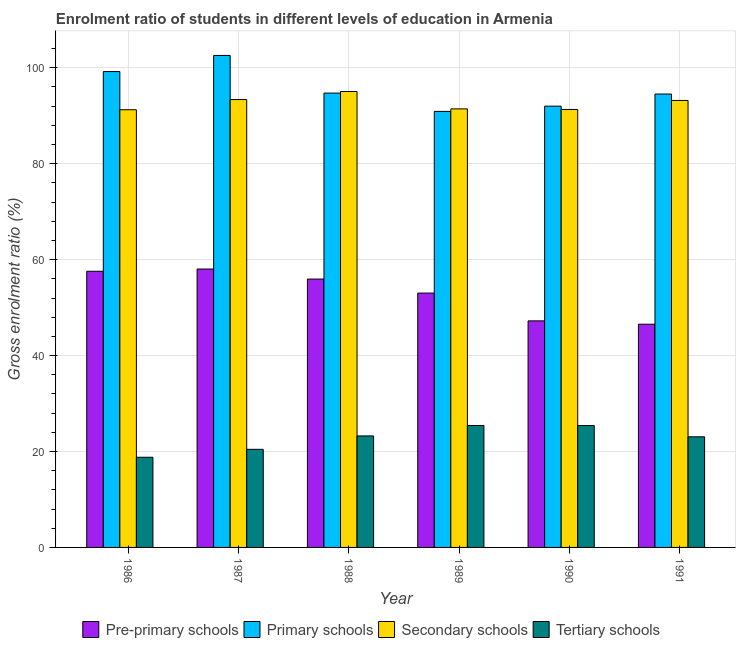How many groups of bars are there?
Keep it short and to the point. 6. Are the number of bars on each tick of the X-axis equal?
Offer a terse response. Yes. How many bars are there on the 3rd tick from the right?
Offer a terse response. 4. What is the label of the 3rd group of bars from the left?
Provide a succinct answer. 1988. In how many cases, is the number of bars for a given year not equal to the number of legend labels?
Your answer should be very brief. 0. What is the gross enrolment ratio in tertiary schools in 1988?
Give a very brief answer. 23.25. Across all years, what is the maximum gross enrolment ratio in secondary schools?
Your answer should be compact. 95.06. Across all years, what is the minimum gross enrolment ratio in pre-primary schools?
Offer a very short reply. 46.54. In which year was the gross enrolment ratio in primary schools maximum?
Offer a very short reply. 1987. In which year was the gross enrolment ratio in primary schools minimum?
Your answer should be very brief. 1989. What is the total gross enrolment ratio in secondary schools in the graph?
Offer a terse response. 555.62. What is the difference between the gross enrolment ratio in pre-primary schools in 1988 and that in 1991?
Your answer should be compact. 9.41. What is the difference between the gross enrolment ratio in primary schools in 1990 and the gross enrolment ratio in tertiary schools in 1987?
Ensure brevity in your answer.  -10.58. What is the average gross enrolment ratio in primary schools per year?
Give a very brief answer. 95.66. In the year 1987, what is the difference between the gross enrolment ratio in pre-primary schools and gross enrolment ratio in primary schools?
Make the answer very short. 0. In how many years, is the gross enrolment ratio in primary schools greater than 4 %?
Provide a short and direct response. 6. What is the ratio of the gross enrolment ratio in primary schools in 1988 to that in 1990?
Ensure brevity in your answer.  1.03. Is the gross enrolment ratio in primary schools in 1989 less than that in 1990?
Ensure brevity in your answer.  Yes. Is the difference between the gross enrolment ratio in secondary schools in 1988 and 1991 greater than the difference between the gross enrolment ratio in primary schools in 1988 and 1991?
Give a very brief answer. No. What is the difference between the highest and the second highest gross enrolment ratio in primary schools?
Make the answer very short. 3.36. What is the difference between the highest and the lowest gross enrolment ratio in primary schools?
Ensure brevity in your answer.  11.67. In how many years, is the gross enrolment ratio in tertiary schools greater than the average gross enrolment ratio in tertiary schools taken over all years?
Your answer should be very brief. 4. Is the sum of the gross enrolment ratio in pre-primary schools in 1989 and 1991 greater than the maximum gross enrolment ratio in tertiary schools across all years?
Provide a short and direct response. Yes. What does the 4th bar from the left in 1990 represents?
Offer a terse response. Tertiary schools. What does the 2nd bar from the right in 1986 represents?
Make the answer very short. Secondary schools. Is it the case that in every year, the sum of the gross enrolment ratio in pre-primary schools and gross enrolment ratio in primary schools is greater than the gross enrolment ratio in secondary schools?
Offer a terse response. Yes. How many bars are there?
Give a very brief answer. 24. How many years are there in the graph?
Your response must be concise. 6. Are the values on the major ticks of Y-axis written in scientific E-notation?
Provide a succinct answer. No. Does the graph contain any zero values?
Give a very brief answer. No. Where does the legend appear in the graph?
Make the answer very short. Bottom center. How many legend labels are there?
Your answer should be compact. 4. What is the title of the graph?
Ensure brevity in your answer.  Enrolment ratio of students in different levels of education in Armenia. What is the label or title of the X-axis?
Offer a very short reply. Year. What is the label or title of the Y-axis?
Your answer should be compact. Gross enrolment ratio (%). What is the Gross enrolment ratio (%) of Pre-primary schools in 1986?
Offer a very short reply. 57.58. What is the Gross enrolment ratio (%) of Primary schools in 1986?
Give a very brief answer. 99.21. What is the Gross enrolment ratio (%) in Secondary schools in 1986?
Provide a short and direct response. 91.25. What is the Gross enrolment ratio (%) in Tertiary schools in 1986?
Your answer should be very brief. 18.8. What is the Gross enrolment ratio (%) of Pre-primary schools in 1987?
Make the answer very short. 58.04. What is the Gross enrolment ratio (%) in Primary schools in 1987?
Make the answer very short. 102.58. What is the Gross enrolment ratio (%) of Secondary schools in 1987?
Your answer should be compact. 93.37. What is the Gross enrolment ratio (%) of Tertiary schools in 1987?
Your answer should be compact. 20.45. What is the Gross enrolment ratio (%) of Pre-primary schools in 1988?
Offer a terse response. 55.95. What is the Gross enrolment ratio (%) of Primary schools in 1988?
Ensure brevity in your answer.  94.73. What is the Gross enrolment ratio (%) in Secondary schools in 1988?
Provide a succinct answer. 95.06. What is the Gross enrolment ratio (%) of Tertiary schools in 1988?
Provide a short and direct response. 23.25. What is the Gross enrolment ratio (%) of Pre-primary schools in 1989?
Offer a terse response. 53.03. What is the Gross enrolment ratio (%) in Primary schools in 1989?
Keep it short and to the point. 90.91. What is the Gross enrolment ratio (%) in Secondary schools in 1989?
Your answer should be compact. 91.43. What is the Gross enrolment ratio (%) of Tertiary schools in 1989?
Your answer should be very brief. 25.42. What is the Gross enrolment ratio (%) in Pre-primary schools in 1990?
Offer a very short reply. 47.23. What is the Gross enrolment ratio (%) in Primary schools in 1990?
Ensure brevity in your answer.  92. What is the Gross enrolment ratio (%) in Secondary schools in 1990?
Give a very brief answer. 91.31. What is the Gross enrolment ratio (%) in Tertiary schools in 1990?
Keep it short and to the point. 25.41. What is the Gross enrolment ratio (%) of Pre-primary schools in 1991?
Give a very brief answer. 46.54. What is the Gross enrolment ratio (%) in Primary schools in 1991?
Provide a succinct answer. 94.53. What is the Gross enrolment ratio (%) of Secondary schools in 1991?
Offer a terse response. 93.19. What is the Gross enrolment ratio (%) of Tertiary schools in 1991?
Your answer should be very brief. 23.06. Across all years, what is the maximum Gross enrolment ratio (%) of Pre-primary schools?
Offer a very short reply. 58.04. Across all years, what is the maximum Gross enrolment ratio (%) in Primary schools?
Keep it short and to the point. 102.58. Across all years, what is the maximum Gross enrolment ratio (%) of Secondary schools?
Provide a succinct answer. 95.06. Across all years, what is the maximum Gross enrolment ratio (%) of Tertiary schools?
Your answer should be very brief. 25.42. Across all years, what is the minimum Gross enrolment ratio (%) of Pre-primary schools?
Your answer should be compact. 46.54. Across all years, what is the minimum Gross enrolment ratio (%) of Primary schools?
Give a very brief answer. 90.91. Across all years, what is the minimum Gross enrolment ratio (%) of Secondary schools?
Provide a succinct answer. 91.25. Across all years, what is the minimum Gross enrolment ratio (%) in Tertiary schools?
Give a very brief answer. 18.8. What is the total Gross enrolment ratio (%) in Pre-primary schools in the graph?
Your answer should be very brief. 318.37. What is the total Gross enrolment ratio (%) in Primary schools in the graph?
Offer a very short reply. 573.95. What is the total Gross enrolment ratio (%) of Secondary schools in the graph?
Ensure brevity in your answer.  555.62. What is the total Gross enrolment ratio (%) of Tertiary schools in the graph?
Your answer should be compact. 136.39. What is the difference between the Gross enrolment ratio (%) of Pre-primary schools in 1986 and that in 1987?
Ensure brevity in your answer.  -0.46. What is the difference between the Gross enrolment ratio (%) of Primary schools in 1986 and that in 1987?
Make the answer very short. -3.36. What is the difference between the Gross enrolment ratio (%) in Secondary schools in 1986 and that in 1987?
Provide a short and direct response. -2.12. What is the difference between the Gross enrolment ratio (%) in Tertiary schools in 1986 and that in 1987?
Offer a terse response. -1.65. What is the difference between the Gross enrolment ratio (%) in Pre-primary schools in 1986 and that in 1988?
Give a very brief answer. 1.63. What is the difference between the Gross enrolment ratio (%) in Primary schools in 1986 and that in 1988?
Offer a very short reply. 4.49. What is the difference between the Gross enrolment ratio (%) in Secondary schools in 1986 and that in 1988?
Provide a short and direct response. -3.81. What is the difference between the Gross enrolment ratio (%) of Tertiary schools in 1986 and that in 1988?
Keep it short and to the point. -4.45. What is the difference between the Gross enrolment ratio (%) of Pre-primary schools in 1986 and that in 1989?
Your answer should be very brief. 4.55. What is the difference between the Gross enrolment ratio (%) of Primary schools in 1986 and that in 1989?
Your answer should be very brief. 8.31. What is the difference between the Gross enrolment ratio (%) in Secondary schools in 1986 and that in 1989?
Give a very brief answer. -0.18. What is the difference between the Gross enrolment ratio (%) of Tertiary schools in 1986 and that in 1989?
Give a very brief answer. -6.62. What is the difference between the Gross enrolment ratio (%) of Pre-primary schools in 1986 and that in 1990?
Make the answer very short. 10.34. What is the difference between the Gross enrolment ratio (%) in Primary schools in 1986 and that in 1990?
Offer a very short reply. 7.21. What is the difference between the Gross enrolment ratio (%) in Secondary schools in 1986 and that in 1990?
Offer a terse response. -0.06. What is the difference between the Gross enrolment ratio (%) of Tertiary schools in 1986 and that in 1990?
Offer a terse response. -6.61. What is the difference between the Gross enrolment ratio (%) of Pre-primary schools in 1986 and that in 1991?
Give a very brief answer. 11.04. What is the difference between the Gross enrolment ratio (%) in Primary schools in 1986 and that in 1991?
Keep it short and to the point. 4.69. What is the difference between the Gross enrolment ratio (%) in Secondary schools in 1986 and that in 1991?
Give a very brief answer. -1.94. What is the difference between the Gross enrolment ratio (%) in Tertiary schools in 1986 and that in 1991?
Provide a short and direct response. -4.27. What is the difference between the Gross enrolment ratio (%) of Pre-primary schools in 1987 and that in 1988?
Offer a terse response. 2.1. What is the difference between the Gross enrolment ratio (%) in Primary schools in 1987 and that in 1988?
Offer a very short reply. 7.85. What is the difference between the Gross enrolment ratio (%) of Secondary schools in 1987 and that in 1988?
Keep it short and to the point. -1.69. What is the difference between the Gross enrolment ratio (%) in Tertiary schools in 1987 and that in 1988?
Ensure brevity in your answer.  -2.79. What is the difference between the Gross enrolment ratio (%) in Pre-primary schools in 1987 and that in 1989?
Provide a short and direct response. 5.01. What is the difference between the Gross enrolment ratio (%) in Primary schools in 1987 and that in 1989?
Offer a very short reply. 11.67. What is the difference between the Gross enrolment ratio (%) of Secondary schools in 1987 and that in 1989?
Offer a terse response. 1.94. What is the difference between the Gross enrolment ratio (%) of Tertiary schools in 1987 and that in 1989?
Provide a succinct answer. -4.97. What is the difference between the Gross enrolment ratio (%) in Pre-primary schools in 1987 and that in 1990?
Ensure brevity in your answer.  10.81. What is the difference between the Gross enrolment ratio (%) of Primary schools in 1987 and that in 1990?
Offer a terse response. 10.58. What is the difference between the Gross enrolment ratio (%) of Secondary schools in 1987 and that in 1990?
Your answer should be compact. 2.06. What is the difference between the Gross enrolment ratio (%) in Tertiary schools in 1987 and that in 1990?
Offer a terse response. -4.95. What is the difference between the Gross enrolment ratio (%) of Pre-primary schools in 1987 and that in 1991?
Provide a succinct answer. 11.5. What is the difference between the Gross enrolment ratio (%) of Primary schools in 1987 and that in 1991?
Provide a short and direct response. 8.05. What is the difference between the Gross enrolment ratio (%) of Secondary schools in 1987 and that in 1991?
Give a very brief answer. 0.18. What is the difference between the Gross enrolment ratio (%) in Tertiary schools in 1987 and that in 1991?
Offer a terse response. -2.61. What is the difference between the Gross enrolment ratio (%) of Pre-primary schools in 1988 and that in 1989?
Make the answer very short. 2.92. What is the difference between the Gross enrolment ratio (%) of Primary schools in 1988 and that in 1989?
Keep it short and to the point. 3.82. What is the difference between the Gross enrolment ratio (%) of Secondary schools in 1988 and that in 1989?
Your answer should be compact. 3.63. What is the difference between the Gross enrolment ratio (%) in Tertiary schools in 1988 and that in 1989?
Provide a succinct answer. -2.17. What is the difference between the Gross enrolment ratio (%) of Pre-primary schools in 1988 and that in 1990?
Keep it short and to the point. 8.71. What is the difference between the Gross enrolment ratio (%) in Primary schools in 1988 and that in 1990?
Offer a very short reply. 2.72. What is the difference between the Gross enrolment ratio (%) in Secondary schools in 1988 and that in 1990?
Your response must be concise. 3.75. What is the difference between the Gross enrolment ratio (%) of Tertiary schools in 1988 and that in 1990?
Offer a terse response. -2.16. What is the difference between the Gross enrolment ratio (%) of Pre-primary schools in 1988 and that in 1991?
Keep it short and to the point. 9.41. What is the difference between the Gross enrolment ratio (%) of Primary schools in 1988 and that in 1991?
Provide a short and direct response. 0.2. What is the difference between the Gross enrolment ratio (%) of Secondary schools in 1988 and that in 1991?
Your response must be concise. 1.87. What is the difference between the Gross enrolment ratio (%) of Tertiary schools in 1988 and that in 1991?
Provide a succinct answer. 0.18. What is the difference between the Gross enrolment ratio (%) of Pre-primary schools in 1989 and that in 1990?
Ensure brevity in your answer.  5.79. What is the difference between the Gross enrolment ratio (%) of Primary schools in 1989 and that in 1990?
Provide a succinct answer. -1.1. What is the difference between the Gross enrolment ratio (%) of Secondary schools in 1989 and that in 1990?
Keep it short and to the point. 0.12. What is the difference between the Gross enrolment ratio (%) of Tertiary schools in 1989 and that in 1990?
Your answer should be very brief. 0.01. What is the difference between the Gross enrolment ratio (%) in Pre-primary schools in 1989 and that in 1991?
Provide a short and direct response. 6.49. What is the difference between the Gross enrolment ratio (%) in Primary schools in 1989 and that in 1991?
Your answer should be very brief. -3.62. What is the difference between the Gross enrolment ratio (%) in Secondary schools in 1989 and that in 1991?
Your response must be concise. -1.76. What is the difference between the Gross enrolment ratio (%) of Tertiary schools in 1989 and that in 1991?
Ensure brevity in your answer.  2.36. What is the difference between the Gross enrolment ratio (%) of Pre-primary schools in 1990 and that in 1991?
Make the answer very short. 0.7. What is the difference between the Gross enrolment ratio (%) of Primary schools in 1990 and that in 1991?
Offer a very short reply. -2.52. What is the difference between the Gross enrolment ratio (%) of Secondary schools in 1990 and that in 1991?
Your response must be concise. -1.88. What is the difference between the Gross enrolment ratio (%) in Tertiary schools in 1990 and that in 1991?
Your response must be concise. 2.34. What is the difference between the Gross enrolment ratio (%) of Pre-primary schools in 1986 and the Gross enrolment ratio (%) of Primary schools in 1987?
Ensure brevity in your answer.  -45. What is the difference between the Gross enrolment ratio (%) of Pre-primary schools in 1986 and the Gross enrolment ratio (%) of Secondary schools in 1987?
Provide a short and direct response. -35.79. What is the difference between the Gross enrolment ratio (%) of Pre-primary schools in 1986 and the Gross enrolment ratio (%) of Tertiary schools in 1987?
Your answer should be very brief. 37.13. What is the difference between the Gross enrolment ratio (%) of Primary schools in 1986 and the Gross enrolment ratio (%) of Secondary schools in 1987?
Provide a short and direct response. 5.84. What is the difference between the Gross enrolment ratio (%) of Primary schools in 1986 and the Gross enrolment ratio (%) of Tertiary schools in 1987?
Your response must be concise. 78.76. What is the difference between the Gross enrolment ratio (%) of Secondary schools in 1986 and the Gross enrolment ratio (%) of Tertiary schools in 1987?
Your answer should be compact. 70.8. What is the difference between the Gross enrolment ratio (%) in Pre-primary schools in 1986 and the Gross enrolment ratio (%) in Primary schools in 1988?
Your response must be concise. -37.15. What is the difference between the Gross enrolment ratio (%) in Pre-primary schools in 1986 and the Gross enrolment ratio (%) in Secondary schools in 1988?
Keep it short and to the point. -37.48. What is the difference between the Gross enrolment ratio (%) in Pre-primary schools in 1986 and the Gross enrolment ratio (%) in Tertiary schools in 1988?
Give a very brief answer. 34.33. What is the difference between the Gross enrolment ratio (%) of Primary schools in 1986 and the Gross enrolment ratio (%) of Secondary schools in 1988?
Ensure brevity in your answer.  4.15. What is the difference between the Gross enrolment ratio (%) in Primary schools in 1986 and the Gross enrolment ratio (%) in Tertiary schools in 1988?
Provide a short and direct response. 75.97. What is the difference between the Gross enrolment ratio (%) of Secondary schools in 1986 and the Gross enrolment ratio (%) of Tertiary schools in 1988?
Your answer should be very brief. 68.01. What is the difference between the Gross enrolment ratio (%) in Pre-primary schools in 1986 and the Gross enrolment ratio (%) in Primary schools in 1989?
Give a very brief answer. -33.33. What is the difference between the Gross enrolment ratio (%) in Pre-primary schools in 1986 and the Gross enrolment ratio (%) in Secondary schools in 1989?
Your answer should be very brief. -33.85. What is the difference between the Gross enrolment ratio (%) in Pre-primary schools in 1986 and the Gross enrolment ratio (%) in Tertiary schools in 1989?
Offer a very short reply. 32.16. What is the difference between the Gross enrolment ratio (%) of Primary schools in 1986 and the Gross enrolment ratio (%) of Secondary schools in 1989?
Offer a very short reply. 7.78. What is the difference between the Gross enrolment ratio (%) of Primary schools in 1986 and the Gross enrolment ratio (%) of Tertiary schools in 1989?
Make the answer very short. 73.79. What is the difference between the Gross enrolment ratio (%) of Secondary schools in 1986 and the Gross enrolment ratio (%) of Tertiary schools in 1989?
Ensure brevity in your answer.  65.83. What is the difference between the Gross enrolment ratio (%) of Pre-primary schools in 1986 and the Gross enrolment ratio (%) of Primary schools in 1990?
Make the answer very short. -34.42. What is the difference between the Gross enrolment ratio (%) in Pre-primary schools in 1986 and the Gross enrolment ratio (%) in Secondary schools in 1990?
Offer a terse response. -33.73. What is the difference between the Gross enrolment ratio (%) of Pre-primary schools in 1986 and the Gross enrolment ratio (%) of Tertiary schools in 1990?
Make the answer very short. 32.17. What is the difference between the Gross enrolment ratio (%) of Primary schools in 1986 and the Gross enrolment ratio (%) of Secondary schools in 1990?
Your answer should be very brief. 7.9. What is the difference between the Gross enrolment ratio (%) in Primary schools in 1986 and the Gross enrolment ratio (%) in Tertiary schools in 1990?
Your answer should be compact. 73.81. What is the difference between the Gross enrolment ratio (%) in Secondary schools in 1986 and the Gross enrolment ratio (%) in Tertiary schools in 1990?
Offer a very short reply. 65.84. What is the difference between the Gross enrolment ratio (%) of Pre-primary schools in 1986 and the Gross enrolment ratio (%) of Primary schools in 1991?
Your response must be concise. -36.95. What is the difference between the Gross enrolment ratio (%) of Pre-primary schools in 1986 and the Gross enrolment ratio (%) of Secondary schools in 1991?
Offer a very short reply. -35.61. What is the difference between the Gross enrolment ratio (%) in Pre-primary schools in 1986 and the Gross enrolment ratio (%) in Tertiary schools in 1991?
Your answer should be compact. 34.51. What is the difference between the Gross enrolment ratio (%) in Primary schools in 1986 and the Gross enrolment ratio (%) in Secondary schools in 1991?
Ensure brevity in your answer.  6.02. What is the difference between the Gross enrolment ratio (%) of Primary schools in 1986 and the Gross enrolment ratio (%) of Tertiary schools in 1991?
Your answer should be compact. 76.15. What is the difference between the Gross enrolment ratio (%) in Secondary schools in 1986 and the Gross enrolment ratio (%) in Tertiary schools in 1991?
Give a very brief answer. 68.19. What is the difference between the Gross enrolment ratio (%) of Pre-primary schools in 1987 and the Gross enrolment ratio (%) of Primary schools in 1988?
Ensure brevity in your answer.  -36.68. What is the difference between the Gross enrolment ratio (%) in Pre-primary schools in 1987 and the Gross enrolment ratio (%) in Secondary schools in 1988?
Make the answer very short. -37.02. What is the difference between the Gross enrolment ratio (%) of Pre-primary schools in 1987 and the Gross enrolment ratio (%) of Tertiary schools in 1988?
Offer a terse response. 34.8. What is the difference between the Gross enrolment ratio (%) in Primary schools in 1987 and the Gross enrolment ratio (%) in Secondary schools in 1988?
Give a very brief answer. 7.52. What is the difference between the Gross enrolment ratio (%) of Primary schools in 1987 and the Gross enrolment ratio (%) of Tertiary schools in 1988?
Your response must be concise. 79.33. What is the difference between the Gross enrolment ratio (%) of Secondary schools in 1987 and the Gross enrolment ratio (%) of Tertiary schools in 1988?
Ensure brevity in your answer.  70.13. What is the difference between the Gross enrolment ratio (%) of Pre-primary schools in 1987 and the Gross enrolment ratio (%) of Primary schools in 1989?
Make the answer very short. -32.86. What is the difference between the Gross enrolment ratio (%) in Pre-primary schools in 1987 and the Gross enrolment ratio (%) in Secondary schools in 1989?
Offer a very short reply. -33.39. What is the difference between the Gross enrolment ratio (%) of Pre-primary schools in 1987 and the Gross enrolment ratio (%) of Tertiary schools in 1989?
Provide a succinct answer. 32.62. What is the difference between the Gross enrolment ratio (%) in Primary schools in 1987 and the Gross enrolment ratio (%) in Secondary schools in 1989?
Provide a short and direct response. 11.15. What is the difference between the Gross enrolment ratio (%) in Primary schools in 1987 and the Gross enrolment ratio (%) in Tertiary schools in 1989?
Make the answer very short. 77.16. What is the difference between the Gross enrolment ratio (%) of Secondary schools in 1987 and the Gross enrolment ratio (%) of Tertiary schools in 1989?
Keep it short and to the point. 67.95. What is the difference between the Gross enrolment ratio (%) of Pre-primary schools in 1987 and the Gross enrolment ratio (%) of Primary schools in 1990?
Provide a succinct answer. -33.96. What is the difference between the Gross enrolment ratio (%) of Pre-primary schools in 1987 and the Gross enrolment ratio (%) of Secondary schools in 1990?
Provide a short and direct response. -33.27. What is the difference between the Gross enrolment ratio (%) in Pre-primary schools in 1987 and the Gross enrolment ratio (%) in Tertiary schools in 1990?
Keep it short and to the point. 32.64. What is the difference between the Gross enrolment ratio (%) of Primary schools in 1987 and the Gross enrolment ratio (%) of Secondary schools in 1990?
Make the answer very short. 11.27. What is the difference between the Gross enrolment ratio (%) of Primary schools in 1987 and the Gross enrolment ratio (%) of Tertiary schools in 1990?
Ensure brevity in your answer.  77.17. What is the difference between the Gross enrolment ratio (%) of Secondary schools in 1987 and the Gross enrolment ratio (%) of Tertiary schools in 1990?
Your answer should be compact. 67.97. What is the difference between the Gross enrolment ratio (%) in Pre-primary schools in 1987 and the Gross enrolment ratio (%) in Primary schools in 1991?
Your answer should be very brief. -36.48. What is the difference between the Gross enrolment ratio (%) in Pre-primary schools in 1987 and the Gross enrolment ratio (%) in Secondary schools in 1991?
Provide a succinct answer. -35.15. What is the difference between the Gross enrolment ratio (%) in Pre-primary schools in 1987 and the Gross enrolment ratio (%) in Tertiary schools in 1991?
Your answer should be compact. 34.98. What is the difference between the Gross enrolment ratio (%) in Primary schools in 1987 and the Gross enrolment ratio (%) in Secondary schools in 1991?
Your answer should be very brief. 9.38. What is the difference between the Gross enrolment ratio (%) of Primary schools in 1987 and the Gross enrolment ratio (%) of Tertiary schools in 1991?
Your response must be concise. 79.51. What is the difference between the Gross enrolment ratio (%) in Secondary schools in 1987 and the Gross enrolment ratio (%) in Tertiary schools in 1991?
Keep it short and to the point. 70.31. What is the difference between the Gross enrolment ratio (%) in Pre-primary schools in 1988 and the Gross enrolment ratio (%) in Primary schools in 1989?
Provide a short and direct response. -34.96. What is the difference between the Gross enrolment ratio (%) of Pre-primary schools in 1988 and the Gross enrolment ratio (%) of Secondary schools in 1989?
Ensure brevity in your answer.  -35.48. What is the difference between the Gross enrolment ratio (%) in Pre-primary schools in 1988 and the Gross enrolment ratio (%) in Tertiary schools in 1989?
Make the answer very short. 30.53. What is the difference between the Gross enrolment ratio (%) of Primary schools in 1988 and the Gross enrolment ratio (%) of Secondary schools in 1989?
Your answer should be compact. 3.29. What is the difference between the Gross enrolment ratio (%) of Primary schools in 1988 and the Gross enrolment ratio (%) of Tertiary schools in 1989?
Keep it short and to the point. 69.3. What is the difference between the Gross enrolment ratio (%) of Secondary schools in 1988 and the Gross enrolment ratio (%) of Tertiary schools in 1989?
Offer a terse response. 69.64. What is the difference between the Gross enrolment ratio (%) in Pre-primary schools in 1988 and the Gross enrolment ratio (%) in Primary schools in 1990?
Your answer should be very brief. -36.05. What is the difference between the Gross enrolment ratio (%) in Pre-primary schools in 1988 and the Gross enrolment ratio (%) in Secondary schools in 1990?
Provide a succinct answer. -35.36. What is the difference between the Gross enrolment ratio (%) in Pre-primary schools in 1988 and the Gross enrolment ratio (%) in Tertiary schools in 1990?
Keep it short and to the point. 30.54. What is the difference between the Gross enrolment ratio (%) of Primary schools in 1988 and the Gross enrolment ratio (%) of Secondary schools in 1990?
Give a very brief answer. 3.42. What is the difference between the Gross enrolment ratio (%) of Primary schools in 1988 and the Gross enrolment ratio (%) of Tertiary schools in 1990?
Your response must be concise. 69.32. What is the difference between the Gross enrolment ratio (%) in Secondary schools in 1988 and the Gross enrolment ratio (%) in Tertiary schools in 1990?
Keep it short and to the point. 69.65. What is the difference between the Gross enrolment ratio (%) of Pre-primary schools in 1988 and the Gross enrolment ratio (%) of Primary schools in 1991?
Ensure brevity in your answer.  -38.58. What is the difference between the Gross enrolment ratio (%) in Pre-primary schools in 1988 and the Gross enrolment ratio (%) in Secondary schools in 1991?
Give a very brief answer. -37.25. What is the difference between the Gross enrolment ratio (%) in Pre-primary schools in 1988 and the Gross enrolment ratio (%) in Tertiary schools in 1991?
Provide a succinct answer. 32.88. What is the difference between the Gross enrolment ratio (%) of Primary schools in 1988 and the Gross enrolment ratio (%) of Secondary schools in 1991?
Your answer should be very brief. 1.53. What is the difference between the Gross enrolment ratio (%) of Primary schools in 1988 and the Gross enrolment ratio (%) of Tertiary schools in 1991?
Keep it short and to the point. 71.66. What is the difference between the Gross enrolment ratio (%) in Secondary schools in 1988 and the Gross enrolment ratio (%) in Tertiary schools in 1991?
Your response must be concise. 71.99. What is the difference between the Gross enrolment ratio (%) of Pre-primary schools in 1989 and the Gross enrolment ratio (%) of Primary schools in 1990?
Ensure brevity in your answer.  -38.97. What is the difference between the Gross enrolment ratio (%) in Pre-primary schools in 1989 and the Gross enrolment ratio (%) in Secondary schools in 1990?
Provide a succinct answer. -38.28. What is the difference between the Gross enrolment ratio (%) of Pre-primary schools in 1989 and the Gross enrolment ratio (%) of Tertiary schools in 1990?
Give a very brief answer. 27.62. What is the difference between the Gross enrolment ratio (%) of Primary schools in 1989 and the Gross enrolment ratio (%) of Secondary schools in 1990?
Your answer should be compact. -0.4. What is the difference between the Gross enrolment ratio (%) in Primary schools in 1989 and the Gross enrolment ratio (%) in Tertiary schools in 1990?
Provide a short and direct response. 65.5. What is the difference between the Gross enrolment ratio (%) of Secondary schools in 1989 and the Gross enrolment ratio (%) of Tertiary schools in 1990?
Make the answer very short. 66.02. What is the difference between the Gross enrolment ratio (%) in Pre-primary schools in 1989 and the Gross enrolment ratio (%) in Primary schools in 1991?
Keep it short and to the point. -41.5. What is the difference between the Gross enrolment ratio (%) of Pre-primary schools in 1989 and the Gross enrolment ratio (%) of Secondary schools in 1991?
Provide a succinct answer. -40.16. What is the difference between the Gross enrolment ratio (%) of Pre-primary schools in 1989 and the Gross enrolment ratio (%) of Tertiary schools in 1991?
Ensure brevity in your answer.  29.96. What is the difference between the Gross enrolment ratio (%) of Primary schools in 1989 and the Gross enrolment ratio (%) of Secondary schools in 1991?
Your answer should be compact. -2.29. What is the difference between the Gross enrolment ratio (%) of Primary schools in 1989 and the Gross enrolment ratio (%) of Tertiary schools in 1991?
Offer a terse response. 67.84. What is the difference between the Gross enrolment ratio (%) in Secondary schools in 1989 and the Gross enrolment ratio (%) in Tertiary schools in 1991?
Keep it short and to the point. 68.37. What is the difference between the Gross enrolment ratio (%) in Pre-primary schools in 1990 and the Gross enrolment ratio (%) in Primary schools in 1991?
Your answer should be compact. -47.29. What is the difference between the Gross enrolment ratio (%) of Pre-primary schools in 1990 and the Gross enrolment ratio (%) of Secondary schools in 1991?
Provide a succinct answer. -45.96. What is the difference between the Gross enrolment ratio (%) in Pre-primary schools in 1990 and the Gross enrolment ratio (%) in Tertiary schools in 1991?
Ensure brevity in your answer.  24.17. What is the difference between the Gross enrolment ratio (%) of Primary schools in 1990 and the Gross enrolment ratio (%) of Secondary schools in 1991?
Ensure brevity in your answer.  -1.19. What is the difference between the Gross enrolment ratio (%) of Primary schools in 1990 and the Gross enrolment ratio (%) of Tertiary schools in 1991?
Ensure brevity in your answer.  68.94. What is the difference between the Gross enrolment ratio (%) of Secondary schools in 1990 and the Gross enrolment ratio (%) of Tertiary schools in 1991?
Keep it short and to the point. 68.25. What is the average Gross enrolment ratio (%) in Pre-primary schools per year?
Your response must be concise. 53.06. What is the average Gross enrolment ratio (%) in Primary schools per year?
Make the answer very short. 95.66. What is the average Gross enrolment ratio (%) of Secondary schools per year?
Provide a succinct answer. 92.6. What is the average Gross enrolment ratio (%) of Tertiary schools per year?
Offer a very short reply. 22.73. In the year 1986, what is the difference between the Gross enrolment ratio (%) of Pre-primary schools and Gross enrolment ratio (%) of Primary schools?
Keep it short and to the point. -41.63. In the year 1986, what is the difference between the Gross enrolment ratio (%) of Pre-primary schools and Gross enrolment ratio (%) of Secondary schools?
Your answer should be very brief. -33.67. In the year 1986, what is the difference between the Gross enrolment ratio (%) of Pre-primary schools and Gross enrolment ratio (%) of Tertiary schools?
Make the answer very short. 38.78. In the year 1986, what is the difference between the Gross enrolment ratio (%) of Primary schools and Gross enrolment ratio (%) of Secondary schools?
Provide a short and direct response. 7.96. In the year 1986, what is the difference between the Gross enrolment ratio (%) of Primary schools and Gross enrolment ratio (%) of Tertiary schools?
Give a very brief answer. 80.41. In the year 1986, what is the difference between the Gross enrolment ratio (%) in Secondary schools and Gross enrolment ratio (%) in Tertiary schools?
Ensure brevity in your answer.  72.45. In the year 1987, what is the difference between the Gross enrolment ratio (%) of Pre-primary schools and Gross enrolment ratio (%) of Primary schools?
Ensure brevity in your answer.  -44.53. In the year 1987, what is the difference between the Gross enrolment ratio (%) of Pre-primary schools and Gross enrolment ratio (%) of Secondary schools?
Provide a short and direct response. -35.33. In the year 1987, what is the difference between the Gross enrolment ratio (%) of Pre-primary schools and Gross enrolment ratio (%) of Tertiary schools?
Give a very brief answer. 37.59. In the year 1987, what is the difference between the Gross enrolment ratio (%) in Primary schools and Gross enrolment ratio (%) in Secondary schools?
Give a very brief answer. 9.2. In the year 1987, what is the difference between the Gross enrolment ratio (%) of Primary schools and Gross enrolment ratio (%) of Tertiary schools?
Your answer should be compact. 82.12. In the year 1987, what is the difference between the Gross enrolment ratio (%) of Secondary schools and Gross enrolment ratio (%) of Tertiary schools?
Offer a terse response. 72.92. In the year 1988, what is the difference between the Gross enrolment ratio (%) in Pre-primary schools and Gross enrolment ratio (%) in Primary schools?
Your answer should be very brief. -38.78. In the year 1988, what is the difference between the Gross enrolment ratio (%) of Pre-primary schools and Gross enrolment ratio (%) of Secondary schools?
Make the answer very short. -39.11. In the year 1988, what is the difference between the Gross enrolment ratio (%) of Pre-primary schools and Gross enrolment ratio (%) of Tertiary schools?
Your answer should be compact. 32.7. In the year 1988, what is the difference between the Gross enrolment ratio (%) of Primary schools and Gross enrolment ratio (%) of Secondary schools?
Your answer should be very brief. -0.33. In the year 1988, what is the difference between the Gross enrolment ratio (%) in Primary schools and Gross enrolment ratio (%) in Tertiary schools?
Give a very brief answer. 71.48. In the year 1988, what is the difference between the Gross enrolment ratio (%) in Secondary schools and Gross enrolment ratio (%) in Tertiary schools?
Your response must be concise. 71.81. In the year 1989, what is the difference between the Gross enrolment ratio (%) of Pre-primary schools and Gross enrolment ratio (%) of Primary schools?
Your response must be concise. -37.88. In the year 1989, what is the difference between the Gross enrolment ratio (%) in Pre-primary schools and Gross enrolment ratio (%) in Secondary schools?
Provide a succinct answer. -38.4. In the year 1989, what is the difference between the Gross enrolment ratio (%) of Pre-primary schools and Gross enrolment ratio (%) of Tertiary schools?
Give a very brief answer. 27.61. In the year 1989, what is the difference between the Gross enrolment ratio (%) in Primary schools and Gross enrolment ratio (%) in Secondary schools?
Offer a very short reply. -0.53. In the year 1989, what is the difference between the Gross enrolment ratio (%) in Primary schools and Gross enrolment ratio (%) in Tertiary schools?
Ensure brevity in your answer.  65.48. In the year 1989, what is the difference between the Gross enrolment ratio (%) in Secondary schools and Gross enrolment ratio (%) in Tertiary schools?
Offer a terse response. 66.01. In the year 1990, what is the difference between the Gross enrolment ratio (%) of Pre-primary schools and Gross enrolment ratio (%) of Primary schools?
Ensure brevity in your answer.  -44.77. In the year 1990, what is the difference between the Gross enrolment ratio (%) in Pre-primary schools and Gross enrolment ratio (%) in Secondary schools?
Offer a terse response. -44.08. In the year 1990, what is the difference between the Gross enrolment ratio (%) of Pre-primary schools and Gross enrolment ratio (%) of Tertiary schools?
Ensure brevity in your answer.  21.83. In the year 1990, what is the difference between the Gross enrolment ratio (%) of Primary schools and Gross enrolment ratio (%) of Secondary schools?
Make the answer very short. 0.69. In the year 1990, what is the difference between the Gross enrolment ratio (%) of Primary schools and Gross enrolment ratio (%) of Tertiary schools?
Offer a terse response. 66.59. In the year 1990, what is the difference between the Gross enrolment ratio (%) in Secondary schools and Gross enrolment ratio (%) in Tertiary schools?
Ensure brevity in your answer.  65.9. In the year 1991, what is the difference between the Gross enrolment ratio (%) in Pre-primary schools and Gross enrolment ratio (%) in Primary schools?
Keep it short and to the point. -47.99. In the year 1991, what is the difference between the Gross enrolment ratio (%) in Pre-primary schools and Gross enrolment ratio (%) in Secondary schools?
Your answer should be compact. -46.66. In the year 1991, what is the difference between the Gross enrolment ratio (%) in Pre-primary schools and Gross enrolment ratio (%) in Tertiary schools?
Keep it short and to the point. 23.47. In the year 1991, what is the difference between the Gross enrolment ratio (%) in Primary schools and Gross enrolment ratio (%) in Secondary schools?
Offer a very short reply. 1.33. In the year 1991, what is the difference between the Gross enrolment ratio (%) in Primary schools and Gross enrolment ratio (%) in Tertiary schools?
Make the answer very short. 71.46. In the year 1991, what is the difference between the Gross enrolment ratio (%) of Secondary schools and Gross enrolment ratio (%) of Tertiary schools?
Ensure brevity in your answer.  70.13. What is the ratio of the Gross enrolment ratio (%) in Primary schools in 1986 to that in 1987?
Your response must be concise. 0.97. What is the ratio of the Gross enrolment ratio (%) of Secondary schools in 1986 to that in 1987?
Provide a short and direct response. 0.98. What is the ratio of the Gross enrolment ratio (%) in Tertiary schools in 1986 to that in 1987?
Your response must be concise. 0.92. What is the ratio of the Gross enrolment ratio (%) of Pre-primary schools in 1986 to that in 1988?
Keep it short and to the point. 1.03. What is the ratio of the Gross enrolment ratio (%) in Primary schools in 1986 to that in 1988?
Your answer should be very brief. 1.05. What is the ratio of the Gross enrolment ratio (%) in Secondary schools in 1986 to that in 1988?
Give a very brief answer. 0.96. What is the ratio of the Gross enrolment ratio (%) of Tertiary schools in 1986 to that in 1988?
Give a very brief answer. 0.81. What is the ratio of the Gross enrolment ratio (%) of Pre-primary schools in 1986 to that in 1989?
Provide a succinct answer. 1.09. What is the ratio of the Gross enrolment ratio (%) in Primary schools in 1986 to that in 1989?
Give a very brief answer. 1.09. What is the ratio of the Gross enrolment ratio (%) of Tertiary schools in 1986 to that in 1989?
Keep it short and to the point. 0.74. What is the ratio of the Gross enrolment ratio (%) of Pre-primary schools in 1986 to that in 1990?
Your answer should be very brief. 1.22. What is the ratio of the Gross enrolment ratio (%) in Primary schools in 1986 to that in 1990?
Make the answer very short. 1.08. What is the ratio of the Gross enrolment ratio (%) of Secondary schools in 1986 to that in 1990?
Keep it short and to the point. 1. What is the ratio of the Gross enrolment ratio (%) of Tertiary schools in 1986 to that in 1990?
Ensure brevity in your answer.  0.74. What is the ratio of the Gross enrolment ratio (%) in Pre-primary schools in 1986 to that in 1991?
Provide a short and direct response. 1.24. What is the ratio of the Gross enrolment ratio (%) in Primary schools in 1986 to that in 1991?
Offer a very short reply. 1.05. What is the ratio of the Gross enrolment ratio (%) of Secondary schools in 1986 to that in 1991?
Provide a short and direct response. 0.98. What is the ratio of the Gross enrolment ratio (%) of Tertiary schools in 1986 to that in 1991?
Your answer should be compact. 0.81. What is the ratio of the Gross enrolment ratio (%) in Pre-primary schools in 1987 to that in 1988?
Your answer should be very brief. 1.04. What is the ratio of the Gross enrolment ratio (%) in Primary schools in 1987 to that in 1988?
Ensure brevity in your answer.  1.08. What is the ratio of the Gross enrolment ratio (%) in Secondary schools in 1987 to that in 1988?
Offer a very short reply. 0.98. What is the ratio of the Gross enrolment ratio (%) in Tertiary schools in 1987 to that in 1988?
Offer a very short reply. 0.88. What is the ratio of the Gross enrolment ratio (%) of Pre-primary schools in 1987 to that in 1989?
Your answer should be compact. 1.09. What is the ratio of the Gross enrolment ratio (%) of Primary schools in 1987 to that in 1989?
Your answer should be compact. 1.13. What is the ratio of the Gross enrolment ratio (%) in Secondary schools in 1987 to that in 1989?
Your answer should be very brief. 1.02. What is the ratio of the Gross enrolment ratio (%) of Tertiary schools in 1987 to that in 1989?
Keep it short and to the point. 0.8. What is the ratio of the Gross enrolment ratio (%) of Pre-primary schools in 1987 to that in 1990?
Make the answer very short. 1.23. What is the ratio of the Gross enrolment ratio (%) of Primary schools in 1987 to that in 1990?
Provide a succinct answer. 1.11. What is the ratio of the Gross enrolment ratio (%) of Secondary schools in 1987 to that in 1990?
Your answer should be very brief. 1.02. What is the ratio of the Gross enrolment ratio (%) of Tertiary schools in 1987 to that in 1990?
Give a very brief answer. 0.81. What is the ratio of the Gross enrolment ratio (%) in Pre-primary schools in 1987 to that in 1991?
Offer a very short reply. 1.25. What is the ratio of the Gross enrolment ratio (%) in Primary schools in 1987 to that in 1991?
Offer a very short reply. 1.09. What is the ratio of the Gross enrolment ratio (%) of Tertiary schools in 1987 to that in 1991?
Your answer should be compact. 0.89. What is the ratio of the Gross enrolment ratio (%) of Pre-primary schools in 1988 to that in 1989?
Keep it short and to the point. 1.05. What is the ratio of the Gross enrolment ratio (%) of Primary schools in 1988 to that in 1989?
Give a very brief answer. 1.04. What is the ratio of the Gross enrolment ratio (%) in Secondary schools in 1988 to that in 1989?
Ensure brevity in your answer.  1.04. What is the ratio of the Gross enrolment ratio (%) in Tertiary schools in 1988 to that in 1989?
Your answer should be very brief. 0.91. What is the ratio of the Gross enrolment ratio (%) in Pre-primary schools in 1988 to that in 1990?
Make the answer very short. 1.18. What is the ratio of the Gross enrolment ratio (%) in Primary schools in 1988 to that in 1990?
Ensure brevity in your answer.  1.03. What is the ratio of the Gross enrolment ratio (%) of Secondary schools in 1988 to that in 1990?
Give a very brief answer. 1.04. What is the ratio of the Gross enrolment ratio (%) in Tertiary schools in 1988 to that in 1990?
Provide a succinct answer. 0.92. What is the ratio of the Gross enrolment ratio (%) of Pre-primary schools in 1988 to that in 1991?
Ensure brevity in your answer.  1.2. What is the ratio of the Gross enrolment ratio (%) in Primary schools in 1988 to that in 1991?
Make the answer very short. 1. What is the ratio of the Gross enrolment ratio (%) of Secondary schools in 1988 to that in 1991?
Ensure brevity in your answer.  1.02. What is the ratio of the Gross enrolment ratio (%) in Tertiary schools in 1988 to that in 1991?
Give a very brief answer. 1.01. What is the ratio of the Gross enrolment ratio (%) of Pre-primary schools in 1989 to that in 1990?
Offer a very short reply. 1.12. What is the ratio of the Gross enrolment ratio (%) of Primary schools in 1989 to that in 1990?
Offer a very short reply. 0.99. What is the ratio of the Gross enrolment ratio (%) of Secondary schools in 1989 to that in 1990?
Your answer should be compact. 1. What is the ratio of the Gross enrolment ratio (%) in Pre-primary schools in 1989 to that in 1991?
Provide a short and direct response. 1.14. What is the ratio of the Gross enrolment ratio (%) in Primary schools in 1989 to that in 1991?
Ensure brevity in your answer.  0.96. What is the ratio of the Gross enrolment ratio (%) of Secondary schools in 1989 to that in 1991?
Keep it short and to the point. 0.98. What is the ratio of the Gross enrolment ratio (%) in Tertiary schools in 1989 to that in 1991?
Your response must be concise. 1.1. What is the ratio of the Gross enrolment ratio (%) of Pre-primary schools in 1990 to that in 1991?
Your response must be concise. 1.01. What is the ratio of the Gross enrolment ratio (%) of Primary schools in 1990 to that in 1991?
Your response must be concise. 0.97. What is the ratio of the Gross enrolment ratio (%) in Secondary schools in 1990 to that in 1991?
Keep it short and to the point. 0.98. What is the ratio of the Gross enrolment ratio (%) of Tertiary schools in 1990 to that in 1991?
Keep it short and to the point. 1.1. What is the difference between the highest and the second highest Gross enrolment ratio (%) of Pre-primary schools?
Keep it short and to the point. 0.46. What is the difference between the highest and the second highest Gross enrolment ratio (%) in Primary schools?
Keep it short and to the point. 3.36. What is the difference between the highest and the second highest Gross enrolment ratio (%) in Secondary schools?
Your answer should be compact. 1.69. What is the difference between the highest and the second highest Gross enrolment ratio (%) in Tertiary schools?
Keep it short and to the point. 0.01. What is the difference between the highest and the lowest Gross enrolment ratio (%) of Pre-primary schools?
Offer a very short reply. 11.5. What is the difference between the highest and the lowest Gross enrolment ratio (%) of Primary schools?
Make the answer very short. 11.67. What is the difference between the highest and the lowest Gross enrolment ratio (%) in Secondary schools?
Offer a terse response. 3.81. What is the difference between the highest and the lowest Gross enrolment ratio (%) in Tertiary schools?
Ensure brevity in your answer.  6.62. 